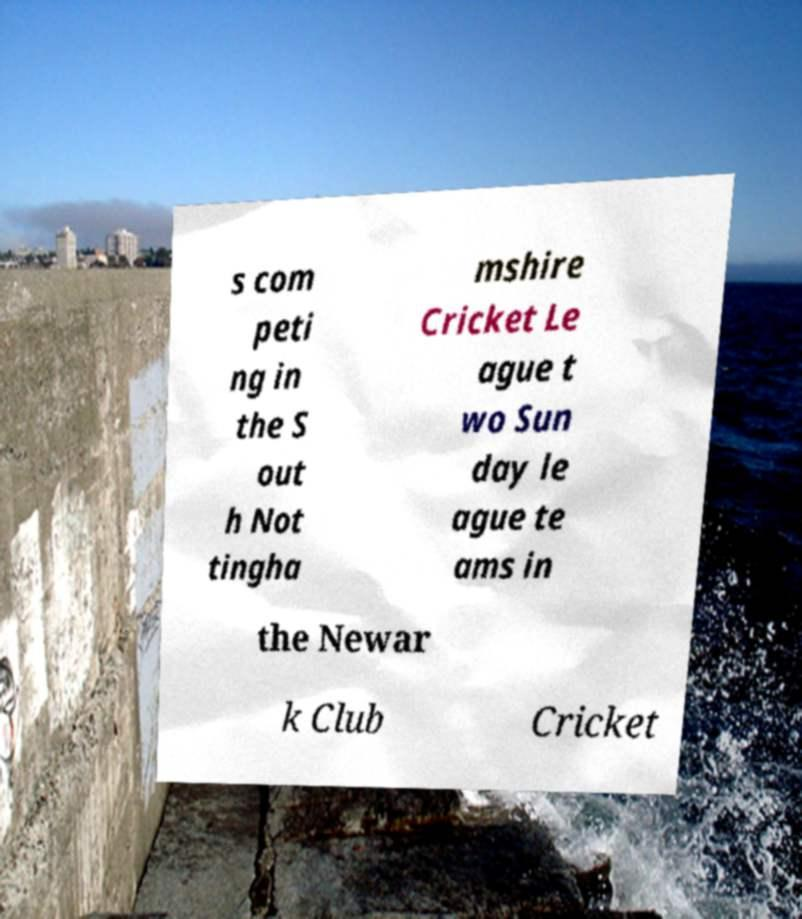Can you accurately transcribe the text from the provided image for me? s com peti ng in the S out h Not tingha mshire Cricket Le ague t wo Sun day le ague te ams in the Newar k Club Cricket 